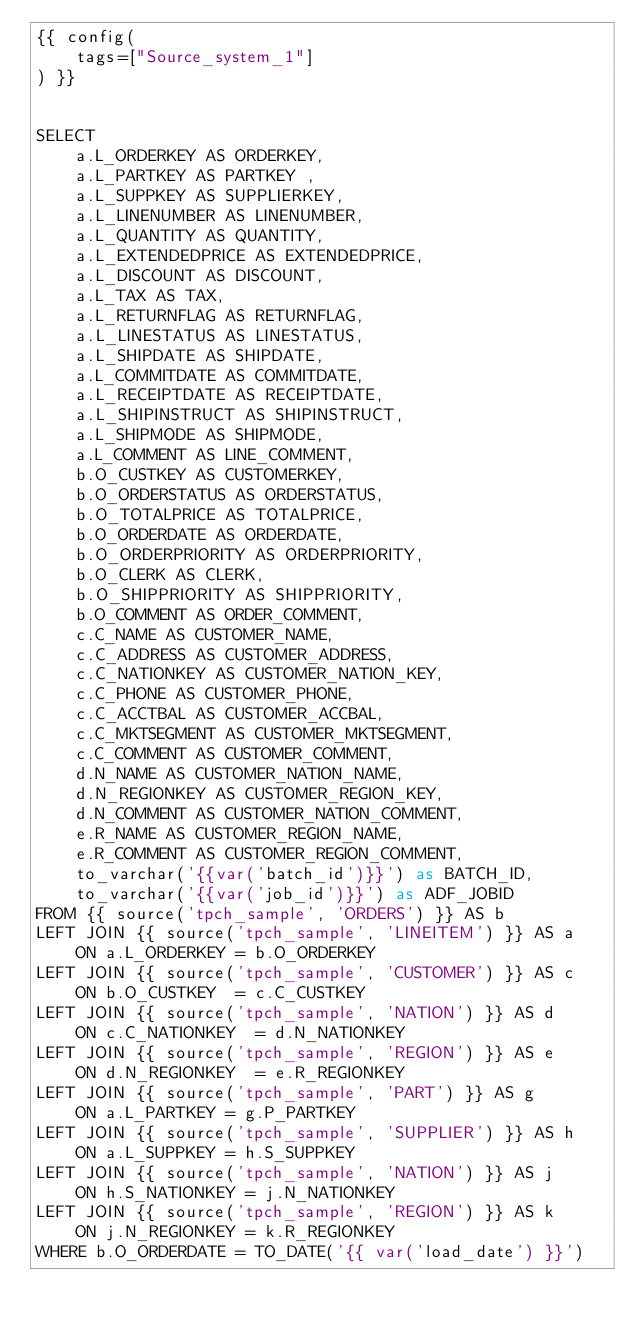<code> <loc_0><loc_0><loc_500><loc_500><_SQL_>{{ config(
    tags=["Source_system_1"]
) }}


SELECT
    a.L_ORDERKEY AS ORDERKEY,
    a.L_PARTKEY AS PARTKEY ,
    a.L_SUPPKEY AS SUPPLIERKEY,
    a.L_LINENUMBER AS LINENUMBER,
    a.L_QUANTITY AS QUANTITY,
    a.L_EXTENDEDPRICE AS EXTENDEDPRICE,
    a.L_DISCOUNT AS DISCOUNT,
    a.L_TAX AS TAX,
    a.L_RETURNFLAG AS RETURNFLAG,
    a.L_LINESTATUS AS LINESTATUS,
    a.L_SHIPDATE AS SHIPDATE,
    a.L_COMMITDATE AS COMMITDATE,
    a.L_RECEIPTDATE AS RECEIPTDATE,
    a.L_SHIPINSTRUCT AS SHIPINSTRUCT,
    a.L_SHIPMODE AS SHIPMODE,
    a.L_COMMENT AS LINE_COMMENT,
    b.O_CUSTKEY AS CUSTOMERKEY,
    b.O_ORDERSTATUS AS ORDERSTATUS,
    b.O_TOTALPRICE AS TOTALPRICE,
    b.O_ORDERDATE AS ORDERDATE,
    b.O_ORDERPRIORITY AS ORDERPRIORITY,
    b.O_CLERK AS CLERK,
    b.O_SHIPPRIORITY AS SHIPPRIORITY,
    b.O_COMMENT AS ORDER_COMMENT,
    c.C_NAME AS CUSTOMER_NAME,
    c.C_ADDRESS AS CUSTOMER_ADDRESS,
    c.C_NATIONKEY AS CUSTOMER_NATION_KEY,
    c.C_PHONE AS CUSTOMER_PHONE,
    c.C_ACCTBAL AS CUSTOMER_ACCBAL,
    c.C_MKTSEGMENT AS CUSTOMER_MKTSEGMENT,
    c.C_COMMENT AS CUSTOMER_COMMENT,
    d.N_NAME AS CUSTOMER_NATION_NAME,
    d.N_REGIONKEY AS CUSTOMER_REGION_KEY,
    d.N_COMMENT AS CUSTOMER_NATION_COMMENT,
    e.R_NAME AS CUSTOMER_REGION_NAME,
    e.R_COMMENT AS CUSTOMER_REGION_COMMENT,
    to_varchar('{{var('batch_id')}}') as BATCH_ID,
    to_varchar('{{var('job_id')}}') as ADF_JOBID
FROM {{ source('tpch_sample', 'ORDERS') }} AS b
LEFT JOIN {{ source('tpch_sample', 'LINEITEM') }} AS a
    ON a.L_ORDERKEY = b.O_ORDERKEY
LEFT JOIN {{ source('tpch_sample', 'CUSTOMER') }} AS c
    ON b.O_CUSTKEY  = c.C_CUSTKEY
LEFT JOIN {{ source('tpch_sample', 'NATION') }} AS d
    ON c.C_NATIONKEY  = d.N_NATIONKEY
LEFT JOIN {{ source('tpch_sample', 'REGION') }} AS e
    ON d.N_REGIONKEY  = e.R_REGIONKEY
LEFT JOIN {{ source('tpch_sample', 'PART') }} AS g
    ON a.L_PARTKEY = g.P_PARTKEY
LEFT JOIN {{ source('tpch_sample', 'SUPPLIER') }} AS h
    ON a.L_SUPPKEY = h.S_SUPPKEY
LEFT JOIN {{ source('tpch_sample', 'NATION') }} AS j
    ON h.S_NATIONKEY = j.N_NATIONKEY
LEFT JOIN {{ source('tpch_sample', 'REGION') }} AS k
    ON j.N_REGIONKEY = k.R_REGIONKEY
WHERE b.O_ORDERDATE = TO_DATE('{{ var('load_date') }}')</code> 